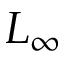Convert formula to latex. <formula><loc_0><loc_0><loc_500><loc_500>L _ { \infty }</formula> 